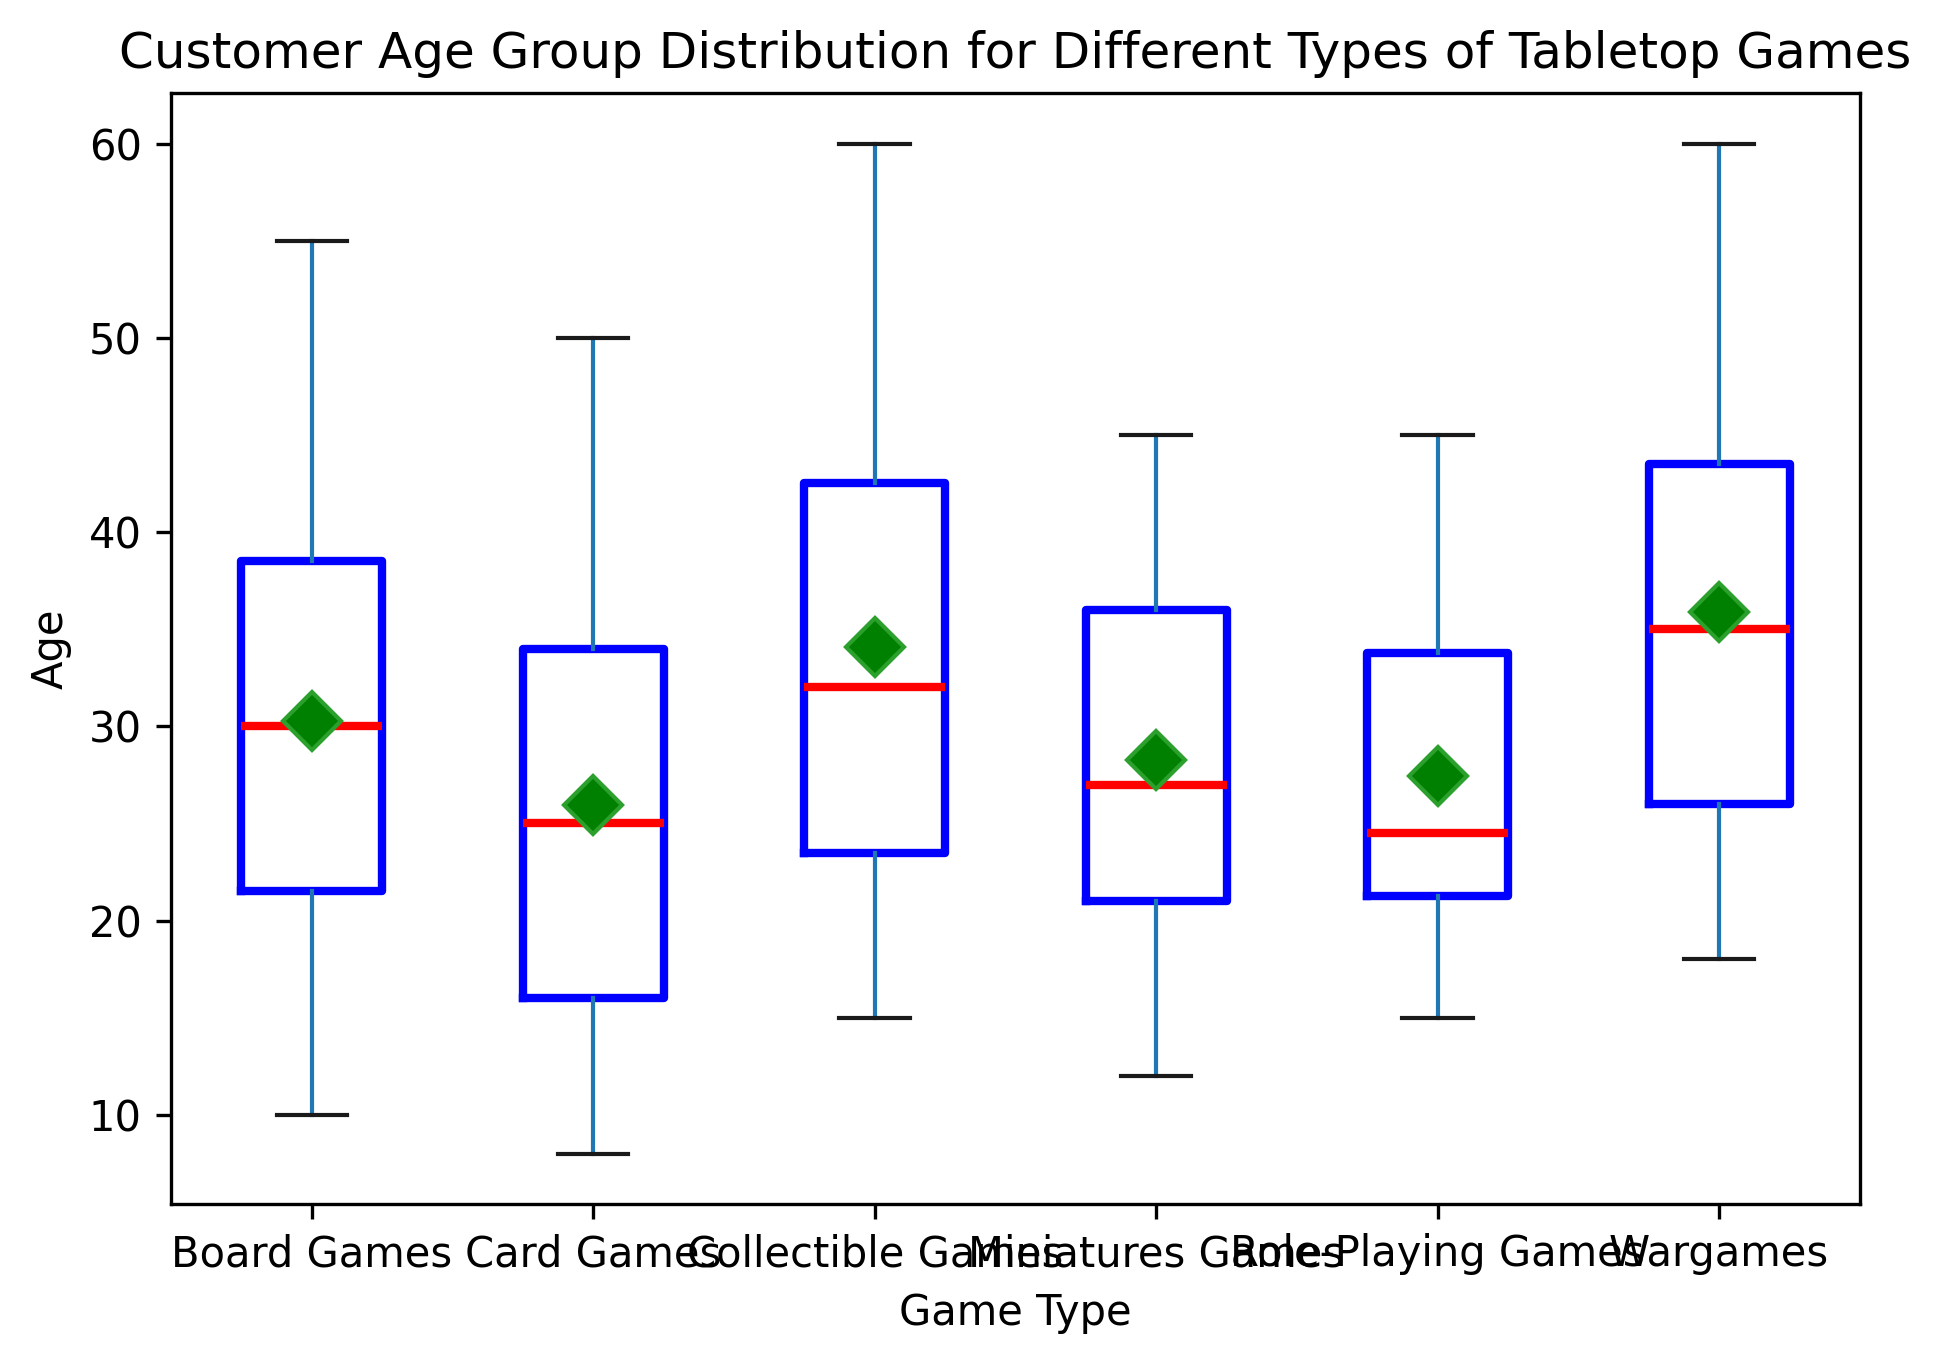What's the median age for Board Games? Locate the median line for the Board Games box plot, which is usually a horizontal line inside the box. In this figure, it appears to be at 32.
Answer: 32 Which game type has the highest median age? Compare the median lines for all game types. The game type with the highest median line is Wargames.
Answer: Wargames Which game type shows the widest range of ages? Determine the range by looking at the distance between the lowest and highest whiskers for each game type. Board Games has the widest range as it spans from 10 to 55.
Answer: Board Games Are there any outliers in Card Games? Outliers are typically represented by individual points outside of the whiskers. There are no outliers in the Card Games box plot.
Answer: No How does the median age for Miniatures Games compare to Role-Playing Games? Look at the horizontal lines representing the medians; the median for Role-Playing Games is slightly higher than that for Miniatures Games.
Answer: Role-Playing Games has a higher median What's the mean age of players for Collectible Games, and how can you tell? The mean is often indicated by a green diamond shape in the box plot. The mean for Collectible Games is around 35.
Answer: 35 Which age group is more variable: Card Games or Collectible Games? Determine variability by looking at the interquartile range (the height of the boxes). Card Games has a taller box indicating more variability.
Answer: Card Games Do any game types have a median age younger than 20? Examine the median lines of each game type. Card Games is the only game type with a median age under 20.
Answer: Card Games Which is more common in this data: older Board Games players or younger Card Games players? Compare the medians and ranges of Board Games and Card Games. Board Games have a higher median and age range, indicating more older players, while Card Games have a lower median, indicating more younger players.
Answer: Older Board Games players 